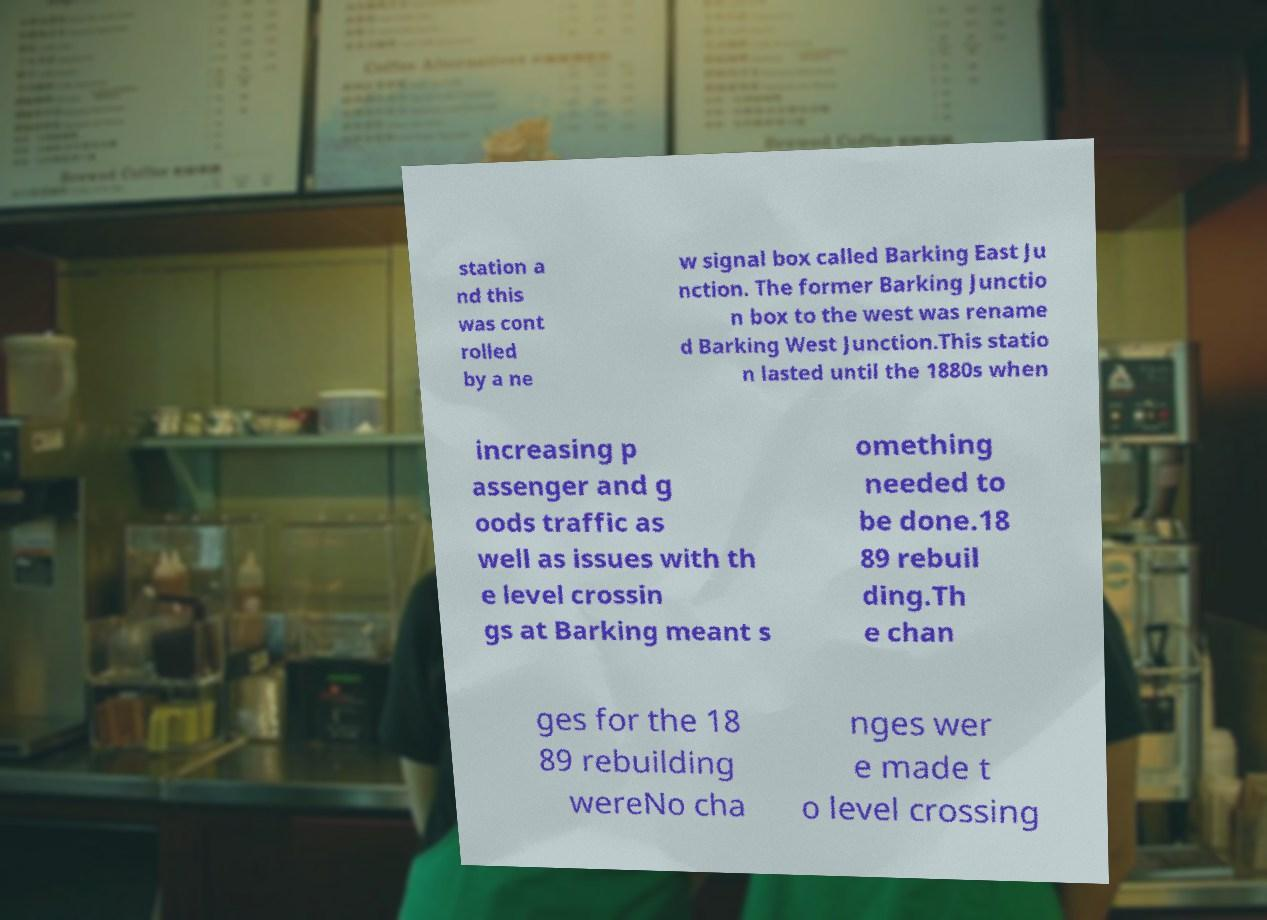Could you assist in decoding the text presented in this image and type it out clearly? station a nd this was cont rolled by a ne w signal box called Barking East Ju nction. The former Barking Junctio n box to the west was rename d Barking West Junction.This statio n lasted until the 1880s when increasing p assenger and g oods traffic as well as issues with th e level crossin gs at Barking meant s omething needed to be done.18 89 rebuil ding.Th e chan ges for the 18 89 rebuilding wereNo cha nges wer e made t o level crossing 